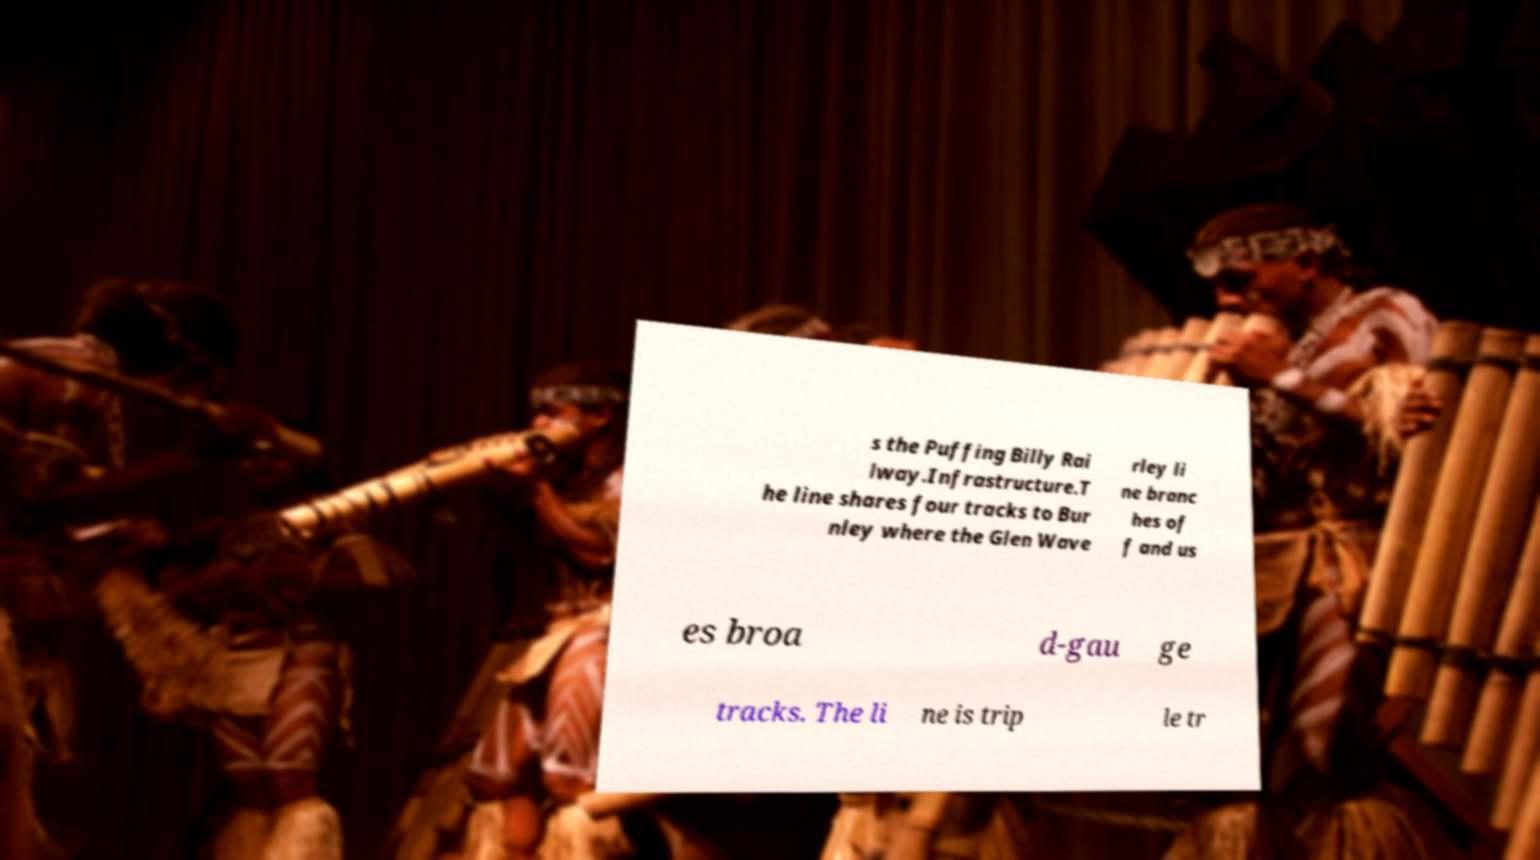Can you read and provide the text displayed in the image?This photo seems to have some interesting text. Can you extract and type it out for me? s the Puffing Billy Rai lway.Infrastructure.T he line shares four tracks to Bur nley where the Glen Wave rley li ne branc hes of f and us es broa d-gau ge tracks. The li ne is trip le tr 